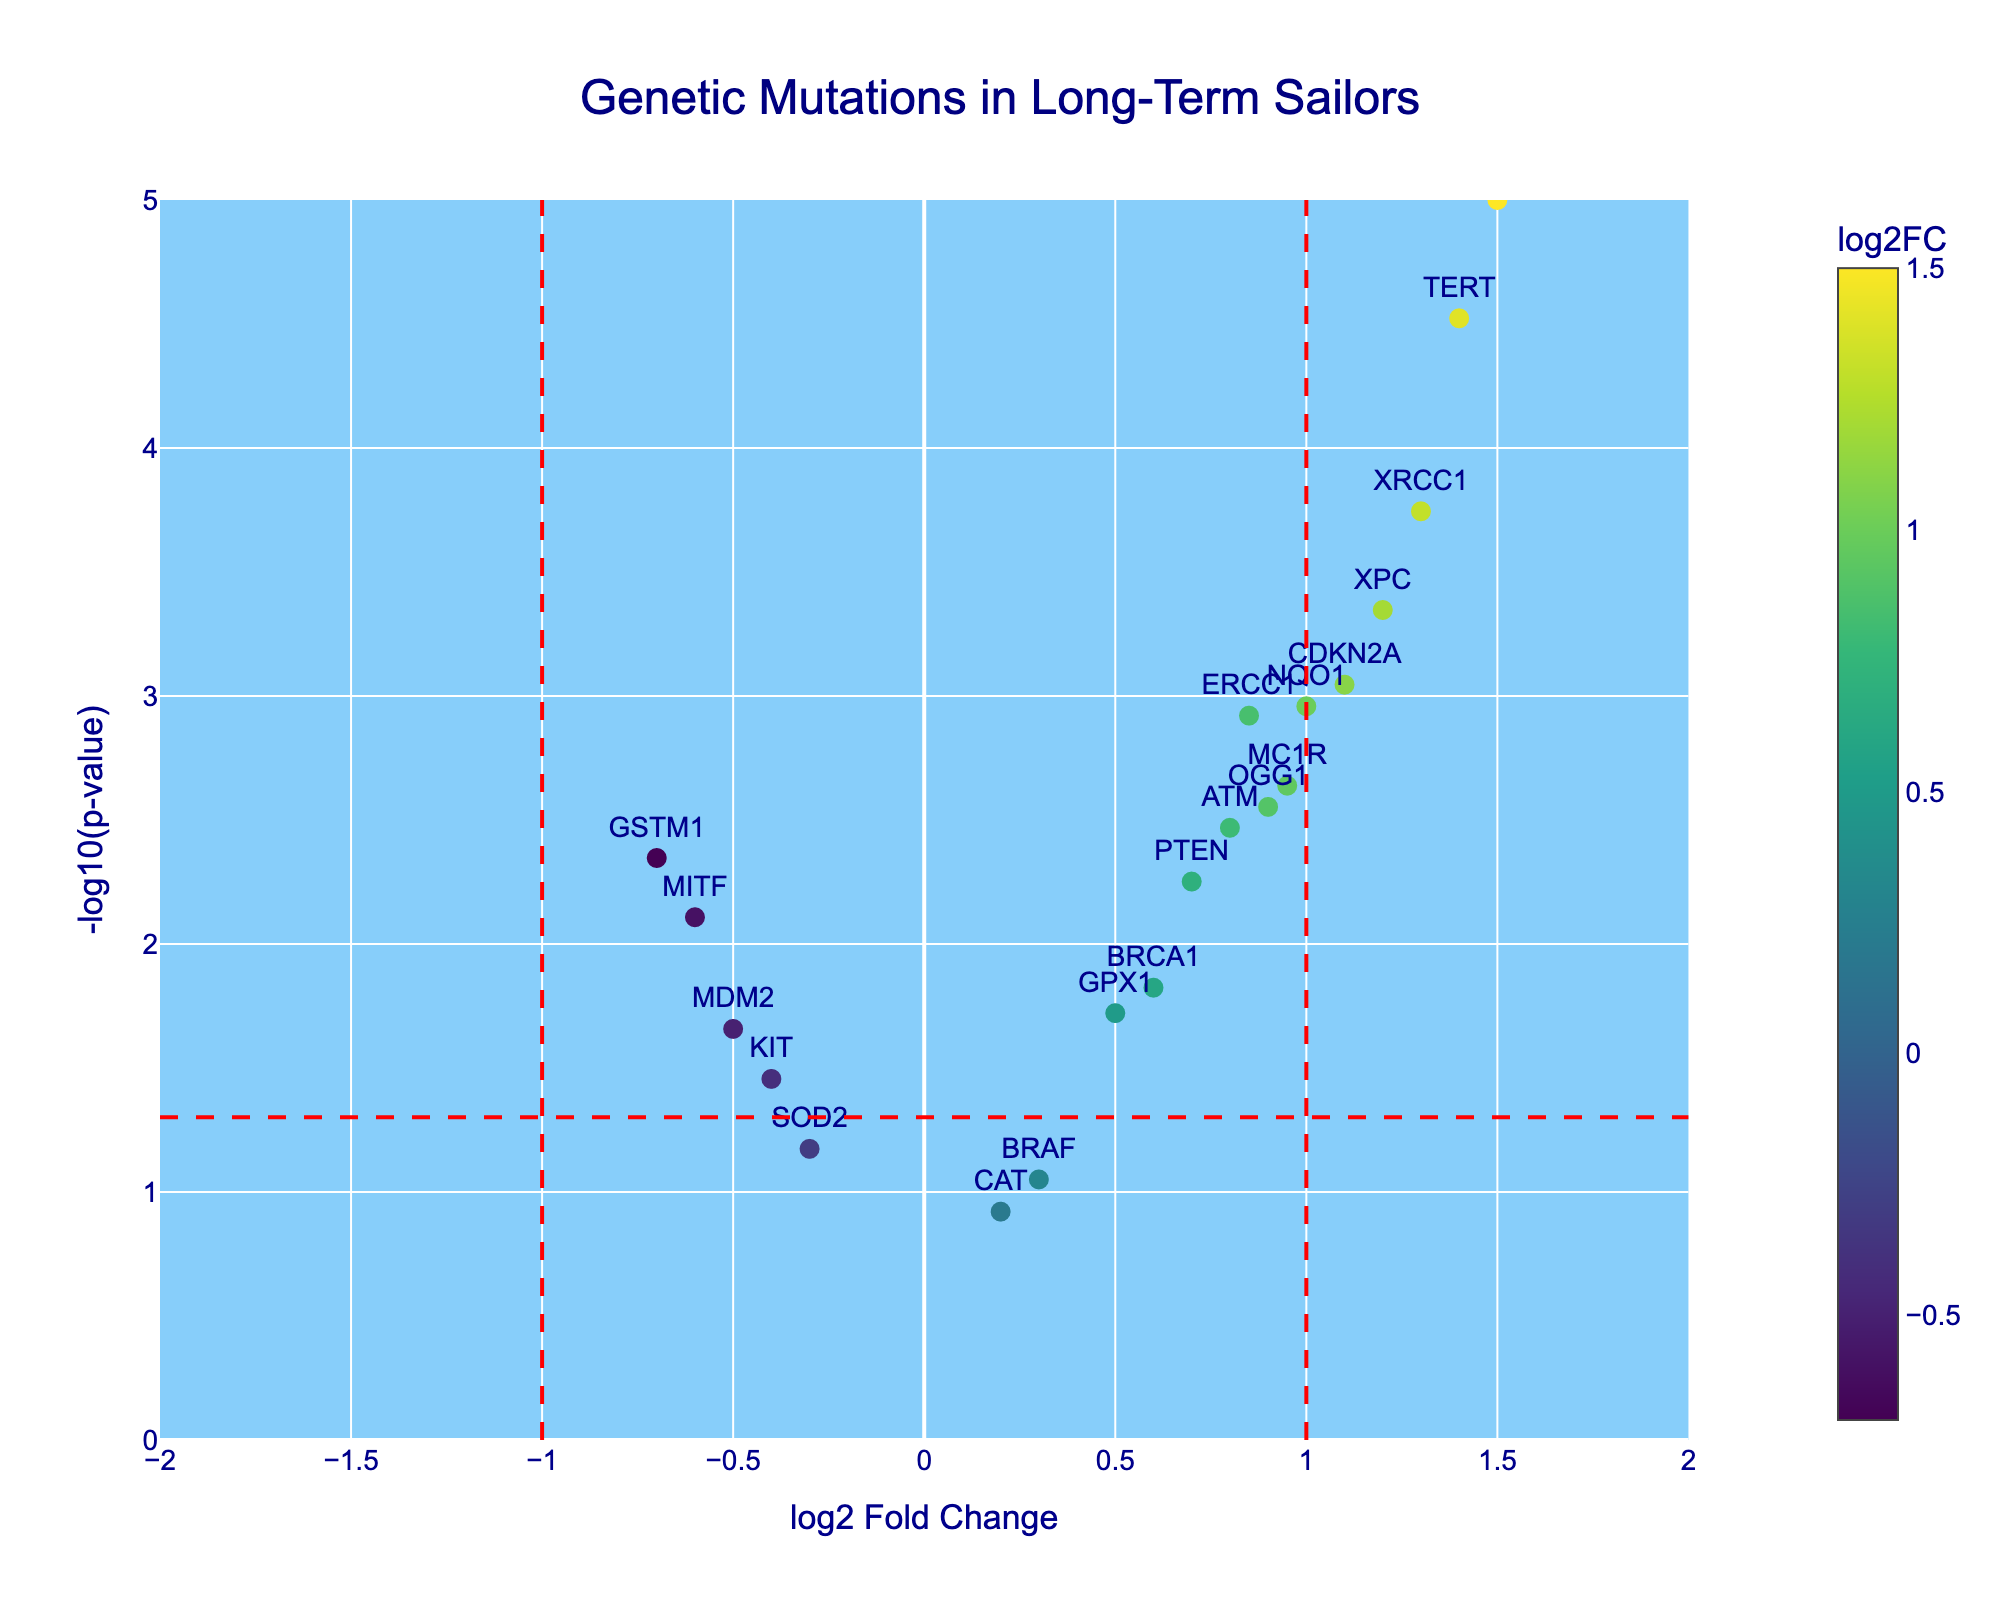What is the title of the figure? The title is found at the top center of the figure and it serves to describe the content of the plot.
Answer: Genetic Mutations in Long-Term Sailors What do the x-axis and y-axis represent? The labels of the axes provide information about what each axis is measuring: 'log2 Fold Change' for the x-axis and '-log10(p-value)' for the y-axis.
Answer: log2 Fold Change (x-axis) and -log10(p-value) (y-axis) How many genes have a -log10(p-value) greater than 3? To answer this, count the data points plotted above the horizontal line corresponding to -log10(0.001) or equal to 3.
Answer: 4 Which gene shows the highest log2 Fold Change? Identify the gene with the highest value on the x-axis.
Answer: TP53 What is the log2 Fold Change and p-value of the gene TERT? Find the specific data point for TERT and read off the x-axis and y-axis values.
Answer: log2 Fold Change: 1.4, p-value: 2.82e-05 Which genes have a log2 Fold Change lower than -0.5? Look for data points that are to the left of x = -0.5.
Answer: MITF, GSTM1 Are there more upregulated or downregulated genes with p-values under 0.05? Upregulated genes will have a log2 Fold Change greater than 0 and a y-axis value above the red horizontal line, while downregulated genes will have a log2 Fold Change less than 0 and a y-axis value above the red horizontal line. Count each type.
Answer: Upregulated Which gene has the smallest p-value? The gene with the highest -log10(p-value) value on the y-axis has the smallest p-value.
Answer: TP53 Are there any genes with a log2 Fold Change between 0.5 and 1.0 and a -log10(p-value) greater than 2? Check for data points with x values between 0.5 and 1.0 and y values greater than 2.
Answer: OGG1, MC1R What does the color scale represent in the plot? The color scale on the right indicates what measure is being visually represented by the colors of the plot markers.
Answer: log2 Fold Change 